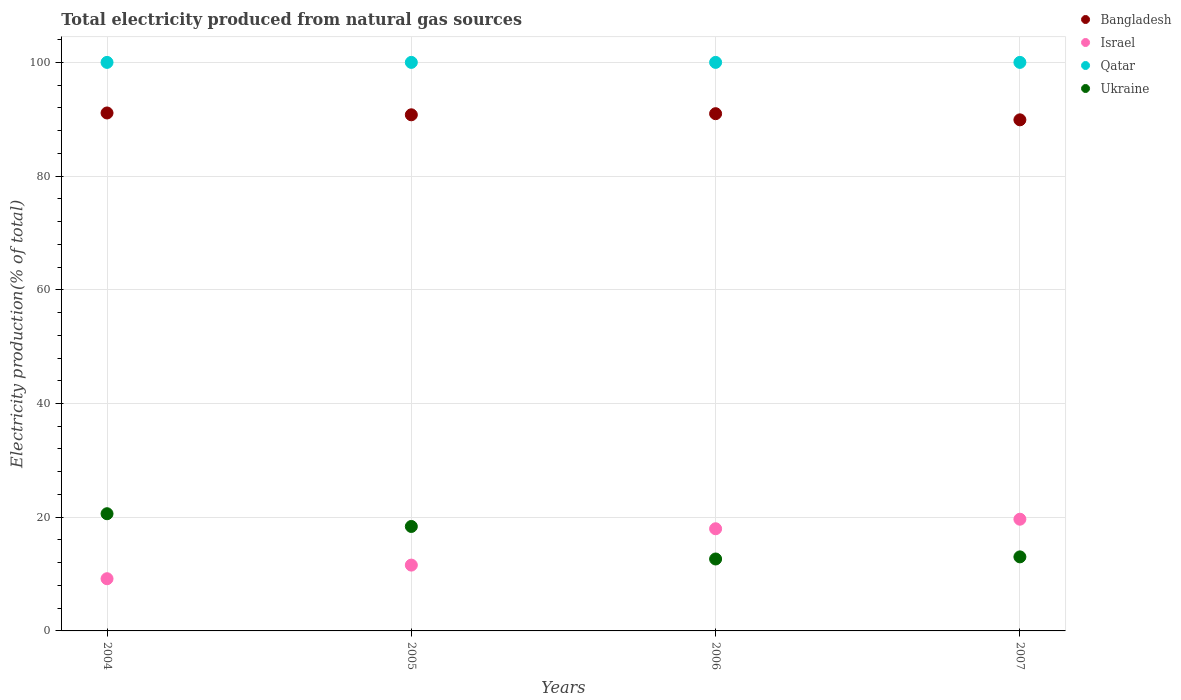What is the total electricity produced in Bangladesh in 2004?
Your answer should be compact. 91.1. Across all years, what is the maximum total electricity produced in Ukraine?
Offer a terse response. 20.61. Across all years, what is the minimum total electricity produced in Ukraine?
Give a very brief answer. 12.65. What is the total total electricity produced in Bangladesh in the graph?
Your response must be concise. 362.76. What is the difference between the total electricity produced in Israel in 2005 and that in 2006?
Give a very brief answer. -6.39. What is the difference between the total electricity produced in Bangladesh in 2005 and the total electricity produced in Qatar in 2007?
Your answer should be very brief. -9.22. What is the average total electricity produced in Qatar per year?
Offer a terse response. 100. In the year 2004, what is the difference between the total electricity produced in Qatar and total electricity produced in Israel?
Provide a succinct answer. 90.82. In how many years, is the total electricity produced in Ukraine greater than 84 %?
Give a very brief answer. 0. Is the total electricity produced in Israel in 2006 less than that in 2007?
Offer a terse response. Yes. What is the difference between the highest and the second highest total electricity produced in Israel?
Offer a terse response. 1.68. In how many years, is the total electricity produced in Qatar greater than the average total electricity produced in Qatar taken over all years?
Ensure brevity in your answer.  0. Is it the case that in every year, the sum of the total electricity produced in Israel and total electricity produced in Bangladesh  is greater than the total electricity produced in Qatar?
Offer a very short reply. Yes. Does the total electricity produced in Qatar monotonically increase over the years?
Keep it short and to the point. No. Is the total electricity produced in Qatar strictly greater than the total electricity produced in Ukraine over the years?
Give a very brief answer. Yes. Is the total electricity produced in Israel strictly less than the total electricity produced in Ukraine over the years?
Ensure brevity in your answer.  No. How many years are there in the graph?
Offer a very short reply. 4. Does the graph contain any zero values?
Offer a terse response. No. How are the legend labels stacked?
Offer a terse response. Vertical. What is the title of the graph?
Offer a terse response. Total electricity produced from natural gas sources. What is the label or title of the X-axis?
Offer a very short reply. Years. What is the Electricity production(% of total) of Bangladesh in 2004?
Your answer should be compact. 91.1. What is the Electricity production(% of total) of Israel in 2004?
Your answer should be compact. 9.18. What is the Electricity production(% of total) of Ukraine in 2004?
Offer a terse response. 20.61. What is the Electricity production(% of total) in Bangladesh in 2005?
Offer a terse response. 90.78. What is the Electricity production(% of total) in Israel in 2005?
Your response must be concise. 11.58. What is the Electricity production(% of total) of Ukraine in 2005?
Your response must be concise. 18.37. What is the Electricity production(% of total) of Bangladesh in 2006?
Offer a terse response. 90.98. What is the Electricity production(% of total) in Israel in 2006?
Offer a terse response. 17.97. What is the Electricity production(% of total) in Qatar in 2006?
Your answer should be very brief. 100. What is the Electricity production(% of total) in Ukraine in 2006?
Ensure brevity in your answer.  12.65. What is the Electricity production(% of total) in Bangladesh in 2007?
Give a very brief answer. 89.9. What is the Electricity production(% of total) in Israel in 2007?
Offer a terse response. 19.65. What is the Electricity production(% of total) of Qatar in 2007?
Give a very brief answer. 100. What is the Electricity production(% of total) in Ukraine in 2007?
Your answer should be very brief. 13.02. Across all years, what is the maximum Electricity production(% of total) of Bangladesh?
Your answer should be compact. 91.1. Across all years, what is the maximum Electricity production(% of total) in Israel?
Provide a succinct answer. 19.65. Across all years, what is the maximum Electricity production(% of total) in Ukraine?
Offer a terse response. 20.61. Across all years, what is the minimum Electricity production(% of total) in Bangladesh?
Your response must be concise. 89.9. Across all years, what is the minimum Electricity production(% of total) in Israel?
Provide a succinct answer. 9.18. Across all years, what is the minimum Electricity production(% of total) of Qatar?
Provide a succinct answer. 100. Across all years, what is the minimum Electricity production(% of total) in Ukraine?
Provide a succinct answer. 12.65. What is the total Electricity production(% of total) in Bangladesh in the graph?
Give a very brief answer. 362.76. What is the total Electricity production(% of total) of Israel in the graph?
Your answer should be very brief. 58.38. What is the total Electricity production(% of total) of Ukraine in the graph?
Your answer should be very brief. 64.66. What is the difference between the Electricity production(% of total) of Bangladesh in 2004 and that in 2005?
Offer a terse response. 0.32. What is the difference between the Electricity production(% of total) in Israel in 2004 and that in 2005?
Your response must be concise. -2.4. What is the difference between the Electricity production(% of total) of Qatar in 2004 and that in 2005?
Offer a terse response. 0. What is the difference between the Electricity production(% of total) of Ukraine in 2004 and that in 2005?
Keep it short and to the point. 2.24. What is the difference between the Electricity production(% of total) of Bangladesh in 2004 and that in 2006?
Offer a terse response. 0.13. What is the difference between the Electricity production(% of total) in Israel in 2004 and that in 2006?
Offer a terse response. -8.79. What is the difference between the Electricity production(% of total) in Qatar in 2004 and that in 2006?
Ensure brevity in your answer.  0. What is the difference between the Electricity production(% of total) in Ukraine in 2004 and that in 2006?
Make the answer very short. 7.96. What is the difference between the Electricity production(% of total) in Bangladesh in 2004 and that in 2007?
Keep it short and to the point. 1.21. What is the difference between the Electricity production(% of total) in Israel in 2004 and that in 2007?
Give a very brief answer. -10.47. What is the difference between the Electricity production(% of total) in Qatar in 2004 and that in 2007?
Your response must be concise. 0. What is the difference between the Electricity production(% of total) in Ukraine in 2004 and that in 2007?
Offer a very short reply. 7.59. What is the difference between the Electricity production(% of total) in Bangladesh in 2005 and that in 2006?
Provide a succinct answer. -0.2. What is the difference between the Electricity production(% of total) of Israel in 2005 and that in 2006?
Offer a very short reply. -6.39. What is the difference between the Electricity production(% of total) in Ukraine in 2005 and that in 2006?
Give a very brief answer. 5.72. What is the difference between the Electricity production(% of total) of Bangladesh in 2005 and that in 2007?
Give a very brief answer. 0.88. What is the difference between the Electricity production(% of total) in Israel in 2005 and that in 2007?
Offer a terse response. -8.07. What is the difference between the Electricity production(% of total) in Qatar in 2005 and that in 2007?
Provide a succinct answer. 0. What is the difference between the Electricity production(% of total) of Ukraine in 2005 and that in 2007?
Give a very brief answer. 5.35. What is the difference between the Electricity production(% of total) in Bangladesh in 2006 and that in 2007?
Ensure brevity in your answer.  1.08. What is the difference between the Electricity production(% of total) in Israel in 2006 and that in 2007?
Ensure brevity in your answer.  -1.68. What is the difference between the Electricity production(% of total) of Qatar in 2006 and that in 2007?
Provide a short and direct response. 0. What is the difference between the Electricity production(% of total) in Ukraine in 2006 and that in 2007?
Your answer should be very brief. -0.37. What is the difference between the Electricity production(% of total) in Bangladesh in 2004 and the Electricity production(% of total) in Israel in 2005?
Give a very brief answer. 79.53. What is the difference between the Electricity production(% of total) of Bangladesh in 2004 and the Electricity production(% of total) of Qatar in 2005?
Offer a terse response. -8.9. What is the difference between the Electricity production(% of total) of Bangladesh in 2004 and the Electricity production(% of total) of Ukraine in 2005?
Your answer should be very brief. 72.73. What is the difference between the Electricity production(% of total) in Israel in 2004 and the Electricity production(% of total) in Qatar in 2005?
Provide a succinct answer. -90.82. What is the difference between the Electricity production(% of total) in Israel in 2004 and the Electricity production(% of total) in Ukraine in 2005?
Provide a short and direct response. -9.19. What is the difference between the Electricity production(% of total) of Qatar in 2004 and the Electricity production(% of total) of Ukraine in 2005?
Give a very brief answer. 81.63. What is the difference between the Electricity production(% of total) in Bangladesh in 2004 and the Electricity production(% of total) in Israel in 2006?
Ensure brevity in your answer.  73.13. What is the difference between the Electricity production(% of total) in Bangladesh in 2004 and the Electricity production(% of total) in Qatar in 2006?
Offer a very short reply. -8.9. What is the difference between the Electricity production(% of total) of Bangladesh in 2004 and the Electricity production(% of total) of Ukraine in 2006?
Keep it short and to the point. 78.45. What is the difference between the Electricity production(% of total) in Israel in 2004 and the Electricity production(% of total) in Qatar in 2006?
Make the answer very short. -90.82. What is the difference between the Electricity production(% of total) in Israel in 2004 and the Electricity production(% of total) in Ukraine in 2006?
Offer a terse response. -3.47. What is the difference between the Electricity production(% of total) in Qatar in 2004 and the Electricity production(% of total) in Ukraine in 2006?
Make the answer very short. 87.35. What is the difference between the Electricity production(% of total) in Bangladesh in 2004 and the Electricity production(% of total) in Israel in 2007?
Offer a very short reply. 71.46. What is the difference between the Electricity production(% of total) of Bangladesh in 2004 and the Electricity production(% of total) of Qatar in 2007?
Offer a terse response. -8.9. What is the difference between the Electricity production(% of total) of Bangladesh in 2004 and the Electricity production(% of total) of Ukraine in 2007?
Ensure brevity in your answer.  78.08. What is the difference between the Electricity production(% of total) of Israel in 2004 and the Electricity production(% of total) of Qatar in 2007?
Keep it short and to the point. -90.82. What is the difference between the Electricity production(% of total) in Israel in 2004 and the Electricity production(% of total) in Ukraine in 2007?
Ensure brevity in your answer.  -3.84. What is the difference between the Electricity production(% of total) in Qatar in 2004 and the Electricity production(% of total) in Ukraine in 2007?
Your answer should be compact. 86.98. What is the difference between the Electricity production(% of total) of Bangladesh in 2005 and the Electricity production(% of total) of Israel in 2006?
Your answer should be compact. 72.81. What is the difference between the Electricity production(% of total) of Bangladesh in 2005 and the Electricity production(% of total) of Qatar in 2006?
Provide a succinct answer. -9.22. What is the difference between the Electricity production(% of total) in Bangladesh in 2005 and the Electricity production(% of total) in Ukraine in 2006?
Your answer should be compact. 78.13. What is the difference between the Electricity production(% of total) of Israel in 2005 and the Electricity production(% of total) of Qatar in 2006?
Your response must be concise. -88.42. What is the difference between the Electricity production(% of total) of Israel in 2005 and the Electricity production(% of total) of Ukraine in 2006?
Offer a very short reply. -1.08. What is the difference between the Electricity production(% of total) of Qatar in 2005 and the Electricity production(% of total) of Ukraine in 2006?
Your answer should be very brief. 87.35. What is the difference between the Electricity production(% of total) in Bangladesh in 2005 and the Electricity production(% of total) in Israel in 2007?
Give a very brief answer. 71.13. What is the difference between the Electricity production(% of total) of Bangladesh in 2005 and the Electricity production(% of total) of Qatar in 2007?
Provide a short and direct response. -9.22. What is the difference between the Electricity production(% of total) of Bangladesh in 2005 and the Electricity production(% of total) of Ukraine in 2007?
Keep it short and to the point. 77.76. What is the difference between the Electricity production(% of total) in Israel in 2005 and the Electricity production(% of total) in Qatar in 2007?
Your response must be concise. -88.42. What is the difference between the Electricity production(% of total) of Israel in 2005 and the Electricity production(% of total) of Ukraine in 2007?
Offer a terse response. -1.45. What is the difference between the Electricity production(% of total) in Qatar in 2005 and the Electricity production(% of total) in Ukraine in 2007?
Offer a very short reply. 86.98. What is the difference between the Electricity production(% of total) of Bangladesh in 2006 and the Electricity production(% of total) of Israel in 2007?
Your answer should be compact. 71.33. What is the difference between the Electricity production(% of total) in Bangladesh in 2006 and the Electricity production(% of total) in Qatar in 2007?
Your response must be concise. -9.02. What is the difference between the Electricity production(% of total) of Bangladesh in 2006 and the Electricity production(% of total) of Ukraine in 2007?
Give a very brief answer. 77.95. What is the difference between the Electricity production(% of total) of Israel in 2006 and the Electricity production(% of total) of Qatar in 2007?
Keep it short and to the point. -82.03. What is the difference between the Electricity production(% of total) in Israel in 2006 and the Electricity production(% of total) in Ukraine in 2007?
Provide a short and direct response. 4.95. What is the difference between the Electricity production(% of total) in Qatar in 2006 and the Electricity production(% of total) in Ukraine in 2007?
Your answer should be very brief. 86.98. What is the average Electricity production(% of total) of Bangladesh per year?
Provide a succinct answer. 90.69. What is the average Electricity production(% of total) of Israel per year?
Give a very brief answer. 14.59. What is the average Electricity production(% of total) of Ukraine per year?
Provide a succinct answer. 16.17. In the year 2004, what is the difference between the Electricity production(% of total) in Bangladesh and Electricity production(% of total) in Israel?
Give a very brief answer. 81.92. In the year 2004, what is the difference between the Electricity production(% of total) in Bangladesh and Electricity production(% of total) in Qatar?
Offer a very short reply. -8.9. In the year 2004, what is the difference between the Electricity production(% of total) in Bangladesh and Electricity production(% of total) in Ukraine?
Ensure brevity in your answer.  70.49. In the year 2004, what is the difference between the Electricity production(% of total) in Israel and Electricity production(% of total) in Qatar?
Offer a very short reply. -90.82. In the year 2004, what is the difference between the Electricity production(% of total) of Israel and Electricity production(% of total) of Ukraine?
Your answer should be compact. -11.43. In the year 2004, what is the difference between the Electricity production(% of total) in Qatar and Electricity production(% of total) in Ukraine?
Make the answer very short. 79.39. In the year 2005, what is the difference between the Electricity production(% of total) of Bangladesh and Electricity production(% of total) of Israel?
Provide a short and direct response. 79.2. In the year 2005, what is the difference between the Electricity production(% of total) in Bangladesh and Electricity production(% of total) in Qatar?
Offer a terse response. -9.22. In the year 2005, what is the difference between the Electricity production(% of total) in Bangladesh and Electricity production(% of total) in Ukraine?
Your response must be concise. 72.41. In the year 2005, what is the difference between the Electricity production(% of total) in Israel and Electricity production(% of total) in Qatar?
Keep it short and to the point. -88.42. In the year 2005, what is the difference between the Electricity production(% of total) of Israel and Electricity production(% of total) of Ukraine?
Offer a terse response. -6.79. In the year 2005, what is the difference between the Electricity production(% of total) in Qatar and Electricity production(% of total) in Ukraine?
Give a very brief answer. 81.63. In the year 2006, what is the difference between the Electricity production(% of total) of Bangladesh and Electricity production(% of total) of Israel?
Provide a succinct answer. 73.01. In the year 2006, what is the difference between the Electricity production(% of total) in Bangladesh and Electricity production(% of total) in Qatar?
Ensure brevity in your answer.  -9.02. In the year 2006, what is the difference between the Electricity production(% of total) of Bangladesh and Electricity production(% of total) of Ukraine?
Offer a terse response. 78.32. In the year 2006, what is the difference between the Electricity production(% of total) of Israel and Electricity production(% of total) of Qatar?
Provide a succinct answer. -82.03. In the year 2006, what is the difference between the Electricity production(% of total) of Israel and Electricity production(% of total) of Ukraine?
Make the answer very short. 5.32. In the year 2006, what is the difference between the Electricity production(% of total) of Qatar and Electricity production(% of total) of Ukraine?
Your answer should be compact. 87.35. In the year 2007, what is the difference between the Electricity production(% of total) in Bangladesh and Electricity production(% of total) in Israel?
Provide a short and direct response. 70.25. In the year 2007, what is the difference between the Electricity production(% of total) in Bangladesh and Electricity production(% of total) in Qatar?
Provide a succinct answer. -10.1. In the year 2007, what is the difference between the Electricity production(% of total) in Bangladesh and Electricity production(% of total) in Ukraine?
Your answer should be very brief. 76.87. In the year 2007, what is the difference between the Electricity production(% of total) in Israel and Electricity production(% of total) in Qatar?
Ensure brevity in your answer.  -80.35. In the year 2007, what is the difference between the Electricity production(% of total) in Israel and Electricity production(% of total) in Ukraine?
Keep it short and to the point. 6.62. In the year 2007, what is the difference between the Electricity production(% of total) of Qatar and Electricity production(% of total) of Ukraine?
Ensure brevity in your answer.  86.98. What is the ratio of the Electricity production(% of total) of Bangladesh in 2004 to that in 2005?
Ensure brevity in your answer.  1. What is the ratio of the Electricity production(% of total) in Israel in 2004 to that in 2005?
Your response must be concise. 0.79. What is the ratio of the Electricity production(% of total) of Qatar in 2004 to that in 2005?
Your response must be concise. 1. What is the ratio of the Electricity production(% of total) in Ukraine in 2004 to that in 2005?
Offer a very short reply. 1.12. What is the ratio of the Electricity production(% of total) of Bangladesh in 2004 to that in 2006?
Make the answer very short. 1. What is the ratio of the Electricity production(% of total) in Israel in 2004 to that in 2006?
Your answer should be compact. 0.51. What is the ratio of the Electricity production(% of total) in Qatar in 2004 to that in 2006?
Provide a succinct answer. 1. What is the ratio of the Electricity production(% of total) in Ukraine in 2004 to that in 2006?
Your answer should be very brief. 1.63. What is the ratio of the Electricity production(% of total) of Bangladesh in 2004 to that in 2007?
Give a very brief answer. 1.01. What is the ratio of the Electricity production(% of total) in Israel in 2004 to that in 2007?
Give a very brief answer. 0.47. What is the ratio of the Electricity production(% of total) of Ukraine in 2004 to that in 2007?
Give a very brief answer. 1.58. What is the ratio of the Electricity production(% of total) in Bangladesh in 2005 to that in 2006?
Your answer should be very brief. 1. What is the ratio of the Electricity production(% of total) in Israel in 2005 to that in 2006?
Offer a very short reply. 0.64. What is the ratio of the Electricity production(% of total) in Ukraine in 2005 to that in 2006?
Make the answer very short. 1.45. What is the ratio of the Electricity production(% of total) in Bangladesh in 2005 to that in 2007?
Offer a terse response. 1.01. What is the ratio of the Electricity production(% of total) in Israel in 2005 to that in 2007?
Give a very brief answer. 0.59. What is the ratio of the Electricity production(% of total) of Ukraine in 2005 to that in 2007?
Make the answer very short. 1.41. What is the ratio of the Electricity production(% of total) of Israel in 2006 to that in 2007?
Your response must be concise. 0.91. What is the ratio of the Electricity production(% of total) of Qatar in 2006 to that in 2007?
Provide a short and direct response. 1. What is the ratio of the Electricity production(% of total) of Ukraine in 2006 to that in 2007?
Offer a terse response. 0.97. What is the difference between the highest and the second highest Electricity production(% of total) in Bangladesh?
Offer a very short reply. 0.13. What is the difference between the highest and the second highest Electricity production(% of total) of Israel?
Provide a short and direct response. 1.68. What is the difference between the highest and the second highest Electricity production(% of total) of Qatar?
Offer a terse response. 0. What is the difference between the highest and the second highest Electricity production(% of total) of Ukraine?
Provide a succinct answer. 2.24. What is the difference between the highest and the lowest Electricity production(% of total) of Bangladesh?
Your response must be concise. 1.21. What is the difference between the highest and the lowest Electricity production(% of total) in Israel?
Offer a very short reply. 10.47. What is the difference between the highest and the lowest Electricity production(% of total) of Qatar?
Provide a succinct answer. 0. What is the difference between the highest and the lowest Electricity production(% of total) of Ukraine?
Your response must be concise. 7.96. 